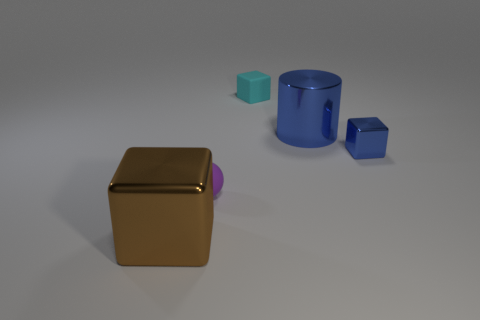Subtract all small cubes. How many cubes are left? 1 Add 3 cyan blocks. How many objects exist? 8 Subtract all cylinders. How many objects are left? 4 Subtract all brown blocks. How many blocks are left? 2 Subtract 2 cubes. How many cubes are left? 1 Subtract all small objects. Subtract all blue cubes. How many objects are left? 1 Add 4 small blue things. How many small blue things are left? 5 Add 2 gray metal spheres. How many gray metal spheres exist? 2 Subtract 0 green blocks. How many objects are left? 5 Subtract all blue balls. Subtract all purple cubes. How many balls are left? 1 